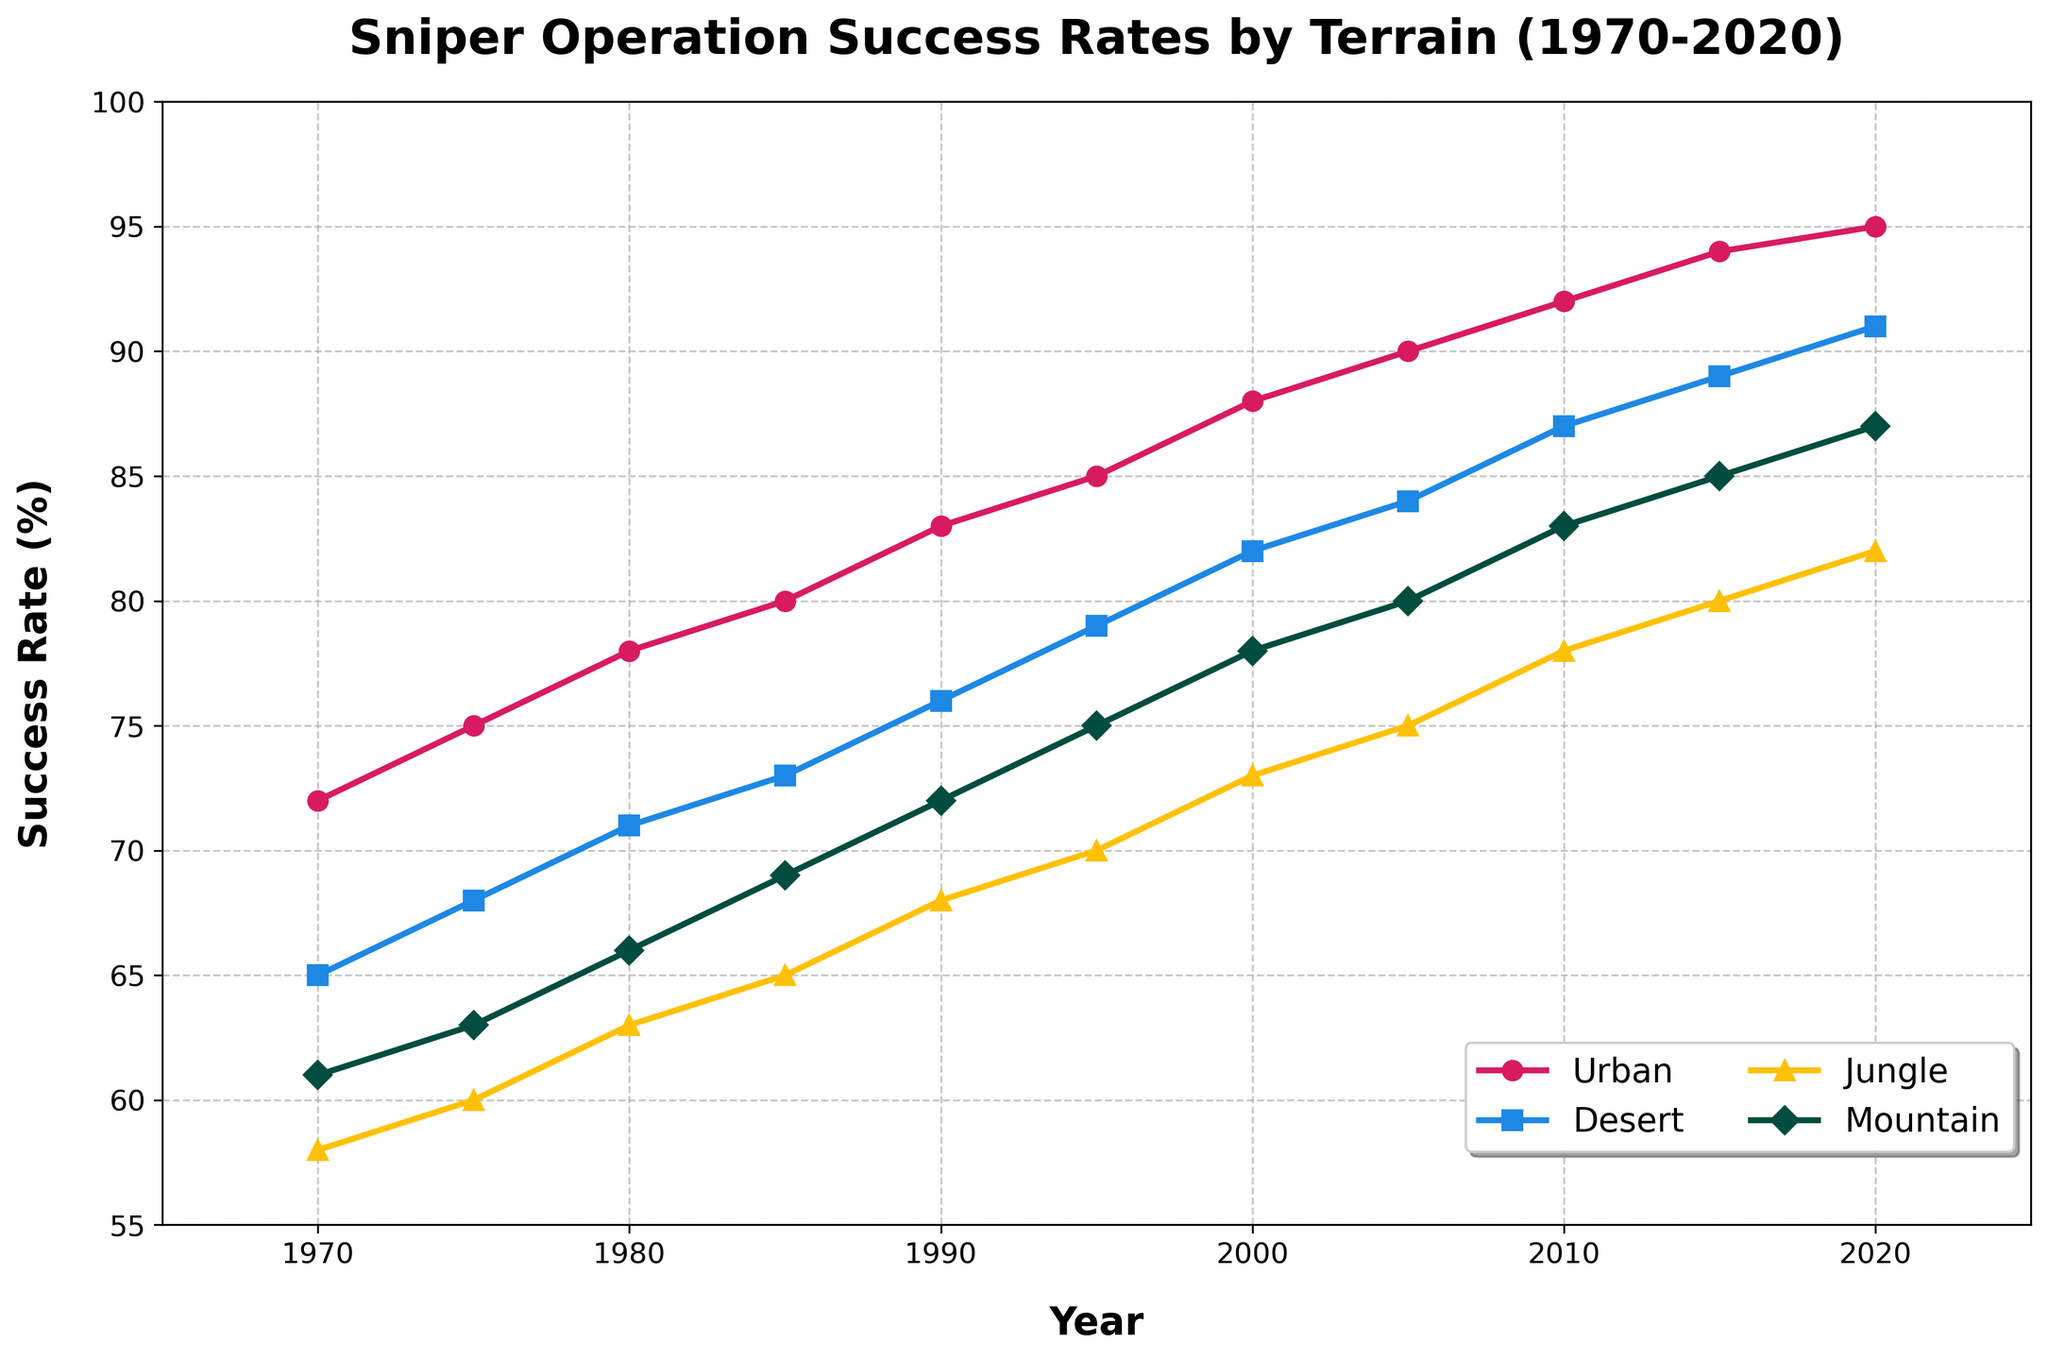What is the success rate in the Urban terrain in 1995? Locate the Urban line on the graph and find the success rate for the year 1995, which is at 85%.
Answer: 85% Which terrain has the highest success rate in 2020? Compare the success rates of Urban, Desert, Jungle, and Mountain terrains for the year 2020. Urban has the highest rate at 95%.
Answer: Urban What is the difference in success rate between Urban and Jungle terrains in 2010? Find the success rates for Urban and Jungle terrains in 2010, which are 92% and 78% respectively. Subtract the Jungle rate from the Urban rate: 92 - 78 = 14%.
Answer: 14% What is the average success rate in the Desert terrain over the years 1980, 1990, and 2000? Find the success rates for the Desert terrain in 1980, 1990, and 2000, which are 71%, 76%, and 82% respectively. Calculate the average: (71 + 76 + 82) / 3 = 229 / 3 ≈ 76.33%.
Answer: 76.33% Which terrain shows the most significant increase in success rate from 1970 to 2020? Compare the differences in success rates from 1970 to 2020 for Urban, Desert, Jungle, and Mountain terrains. Urban terrain increases from 72% to 95%, Desert from 65% to 91%, Jungle from 58% to 82%, and Mountain from 61% to 87%. Urban has the highest increase (95-72=23%).
Answer: Urban Do the Jungle and Mountain terrains ever have the same success rate? Scan the lines for Jungle and Mountain across the timeline to see if they overlap. They do not have the same success rate at any given point.
Answer: No In which year did the Desert terrain success rate first exceed 85%? Trace the Desert terrain's success rate to find the first year it exceeds 85%, which is 2015 with an 89% success rate.
Answer: 2015 What was the success rate trend for Urban terrain from 2000 to 2020? Observe the slope of the Urban line from 2000 (88%) to 2020 (95%). The success rate is consistently increasing.
Answer: Increasing What is the combined success rate of all terrains in 1985? Find the success rates for all terrains in 1985: Urban (80%), Desert (73%), Jungle (65%), and Mountain (69%). Add them together: 80 + 73 + 65 + 69 = 287%.
Answer: 287% By how much did the Mountain terrain success rate improve from 1970 to 1990? Check the Mountain terrain's success rate in 1970 (61%) and 1990 (72%). Calculate the difference: 72 - 61 = 11%.
Answer: 11% 